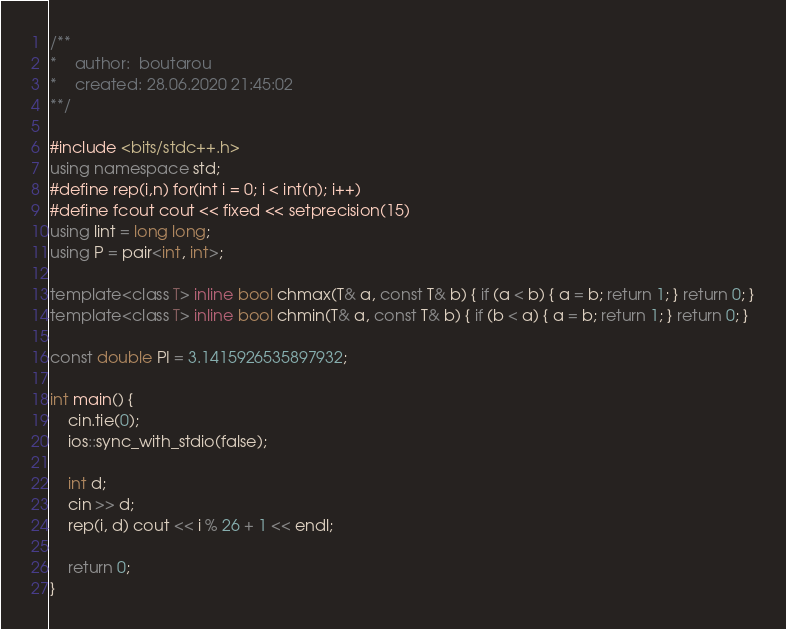<code> <loc_0><loc_0><loc_500><loc_500><_C++_>/**
*    author:  boutarou
*    created: 28.06.2020 21:45:02
**/

#include <bits/stdc++.h>
using namespace std;
#define rep(i,n) for(int i = 0; i < int(n); i++)
#define fcout cout << fixed << setprecision(15)
using lint = long long;
using P = pair<int, int>;

template<class T> inline bool chmax(T& a, const T& b) { if (a < b) { a = b; return 1; } return 0; }
template<class T> inline bool chmin(T& a, const T& b) { if (b < a) { a = b; return 1; } return 0; }

const double PI = 3.1415926535897932;

int main() {
    cin.tie(0);
    ios::sync_with_stdio(false);
    
    int d;
    cin >> d;
    rep(i, d) cout << i % 26 + 1 << endl;
    
    return 0;
}</code> 